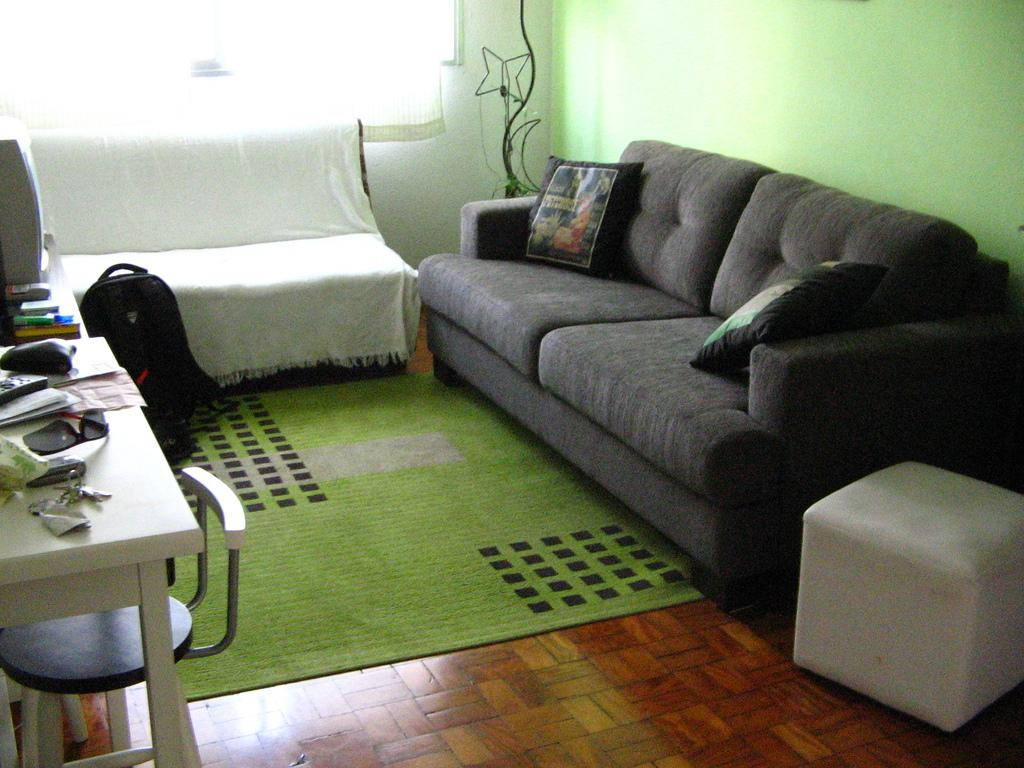What type of furniture is present in the image? There is a sofa set in the image. What other piece of furniture can be seen in the image? There is a table in the image. What is placed on the table in the image? There are papers on the table. What type of personal item is visible in the image? There is a backpack in the image. What type of attraction is present in the image? There is no attraction present in the image; it features a sofa set, a table, papers, and a backpack. Can you tell me how many friends are visible in the image? There is no reference to friends in the image. 